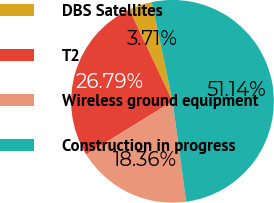Convert chart to OTSL. <chart><loc_0><loc_0><loc_500><loc_500><pie_chart><fcel>DBS Satellites<fcel>T2<fcel>Wireless ground equipment<fcel>Construction in progress<nl><fcel>3.71%<fcel>26.79%<fcel>18.36%<fcel>51.14%<nl></chart> 